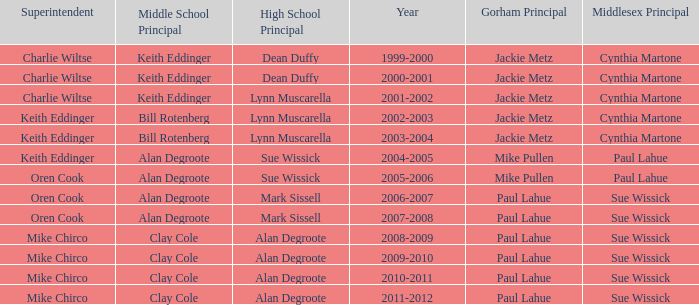How many years was lynn muscarella the high school principal and charlie wiltse the superintendent? 1.0. 